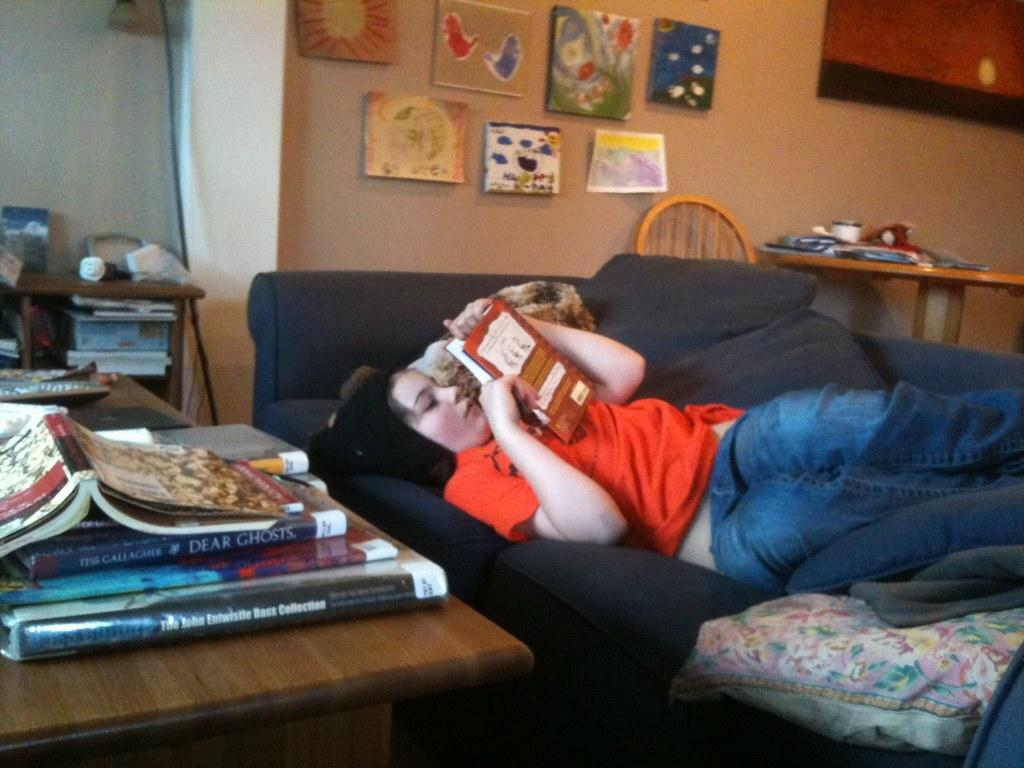<image>
Present a compact description of the photo's key features. a few books, one of which says dear ghosts on it 